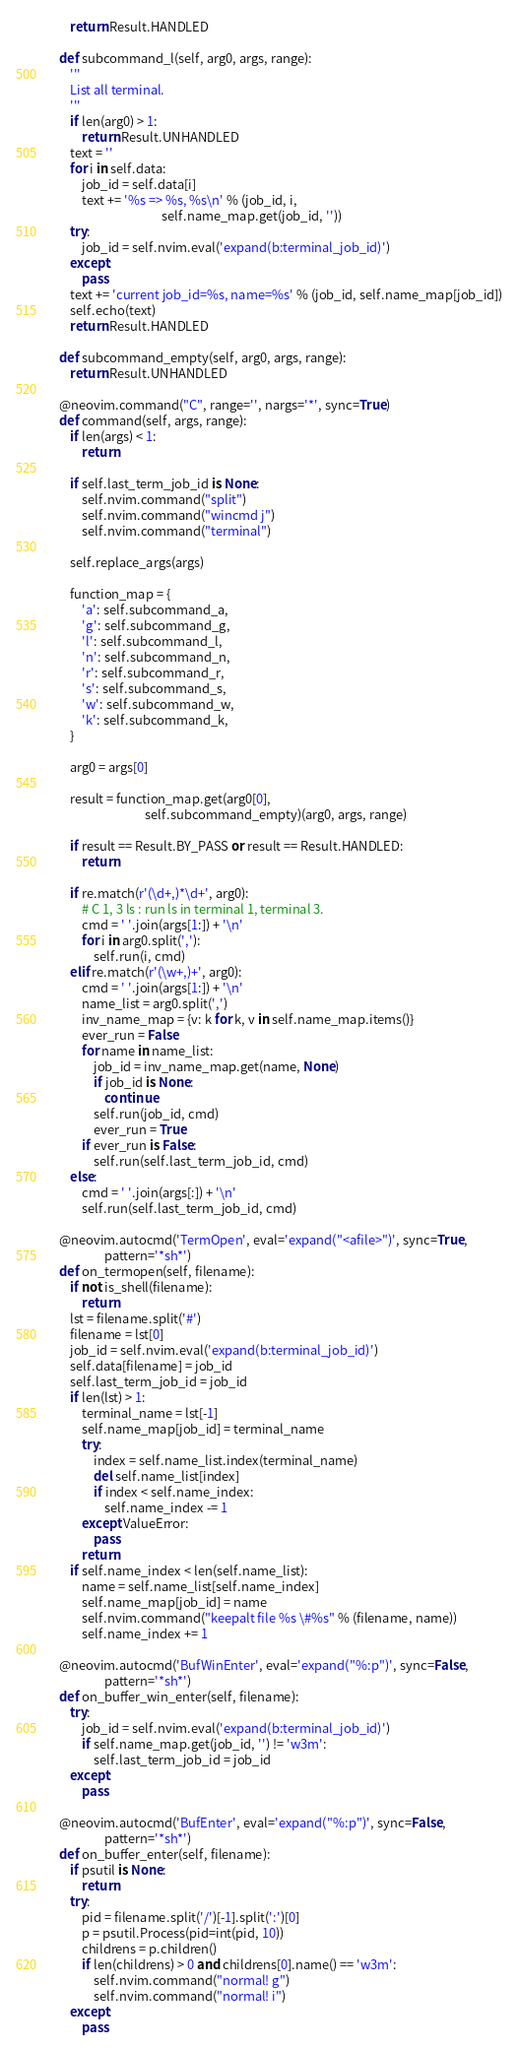<code> <loc_0><loc_0><loc_500><loc_500><_Python_>        return Result.HANDLED

    def subcommand_l(self, arg0, args, range):
        '''
        List all terminal.
        '''
        if len(arg0) > 1:
            return Result.UNHANDLED
        text = ''
        for i in self.data:
            job_id = self.data[i]
            text += '%s => %s, %s\n' % (job_id, i,
                                        self.name_map.get(job_id, ''))
        try:
            job_id = self.nvim.eval('expand(b:terminal_job_id)')
        except:
            pass
        text += 'current job_id=%s, name=%s' % (job_id, self.name_map[job_id])
        self.echo(text)
        return Result.HANDLED

    def subcommand_empty(self, arg0, args, range):
        return Result.UNHANDLED

    @neovim.command("C", range='', nargs='*', sync=True)
    def command(self, args, range):
        if len(args) < 1:
            return

        if self.last_term_job_id is None:
            self.nvim.command("split")
            self.nvim.command("wincmd j")
            self.nvim.command("terminal")

        self.replace_args(args)

        function_map = {
            'a': self.subcommand_a,
            'g': self.subcommand_g,
            'l': self.subcommand_l,
            'n': self.subcommand_n,
            'r': self.subcommand_r,
            's': self.subcommand_s,
            'w': self.subcommand_w,
            'k': self.subcommand_k,
        }

        arg0 = args[0]

        result = function_map.get(arg0[0],
                                  self.subcommand_empty)(arg0, args, range)

        if result == Result.BY_PASS or result == Result.HANDLED:
            return

        if re.match(r'(\d+,)*\d+', arg0):
            # C 1, 3 ls : run ls in terminal 1, terminal 3.
            cmd = ' '.join(args[1:]) + '\n'
            for i in arg0.split(','):
                self.run(i, cmd)
        elif re.match(r'(\w+,)+', arg0):
            cmd = ' '.join(args[1:]) + '\n'
            name_list = arg0.split(',')
            inv_name_map = {v: k for k, v in self.name_map.items()}
            ever_run = False
            for name in name_list:
                job_id = inv_name_map.get(name, None)
                if job_id is None:
                    continue
                self.run(job_id, cmd)
                ever_run = True
            if ever_run is False:
                self.run(self.last_term_job_id, cmd)
        else:
            cmd = ' '.join(args[:]) + '\n'
            self.run(self.last_term_job_id, cmd)

    @neovim.autocmd('TermOpen', eval='expand("<afile>")', sync=True,
                    pattern='*sh*')
    def on_termopen(self, filename):
        if not is_shell(filename):
            return
        lst = filename.split('#')
        filename = lst[0]
        job_id = self.nvim.eval('expand(b:terminal_job_id)')
        self.data[filename] = job_id
        self.last_term_job_id = job_id
        if len(lst) > 1:
            terminal_name = lst[-1]
            self.name_map[job_id] = terminal_name
            try:
                index = self.name_list.index(terminal_name)
                del self.name_list[index]
                if index < self.name_index:
                    self.name_index -= 1
            except ValueError:
                pass
            return
        if self.name_index < len(self.name_list):
            name = self.name_list[self.name_index]
            self.name_map[job_id] = name
            self.nvim.command("keepalt file %s \#%s" % (filename, name))
            self.name_index += 1

    @neovim.autocmd('BufWinEnter', eval='expand("%:p")', sync=False,
                    pattern='*sh*')
    def on_buffer_win_enter(self, filename):
        try:
            job_id = self.nvim.eval('expand(b:terminal_job_id)')
            if self.name_map.get(job_id, '') != 'w3m':
                self.last_term_job_id = job_id
        except:
            pass

    @neovim.autocmd('BufEnter', eval='expand("%:p")', sync=False,
                    pattern='*sh*')
    def on_buffer_enter(self, filename):
        if psutil is None:
            return
        try:
            pid = filename.split('/')[-1].split(':')[0]
            p = psutil.Process(pid=int(pid, 10))
            childrens = p.children()
            if len(childrens) > 0 and childrens[0].name() == 'w3m':
                self.nvim.command("normal! g")
                self.nvim.command("normal! i")
        except:
            pass
</code> 